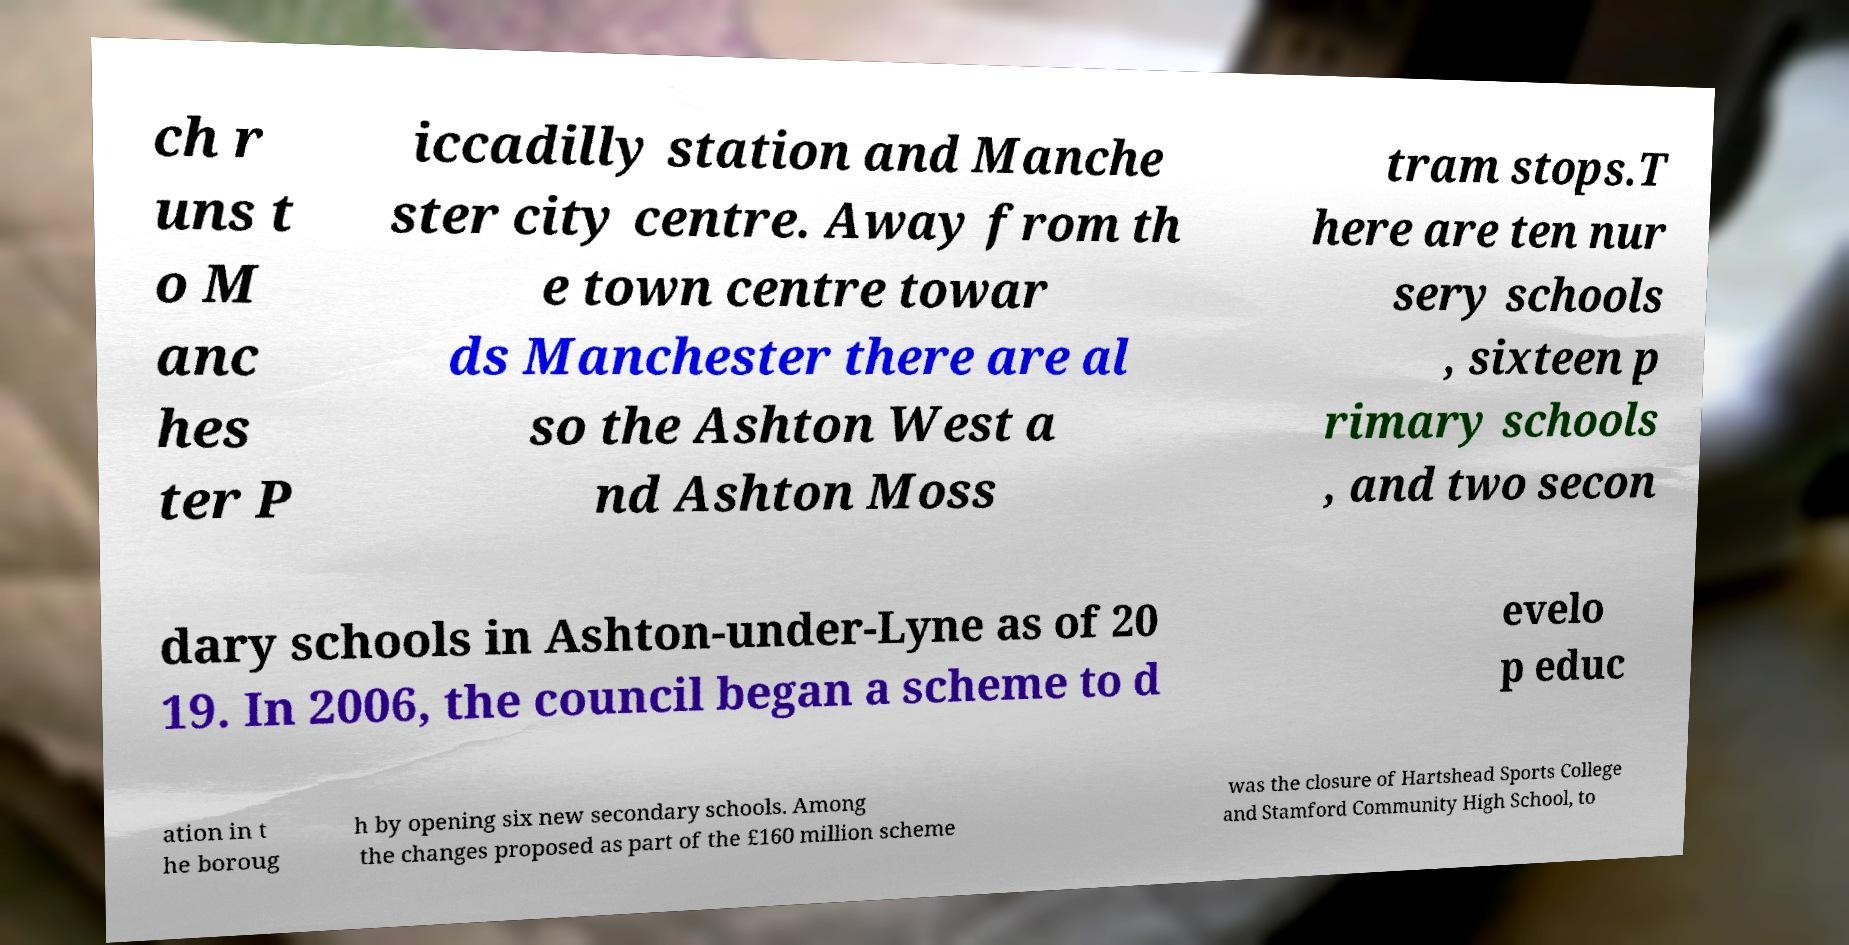Can you read and provide the text displayed in the image?This photo seems to have some interesting text. Can you extract and type it out for me? ch r uns t o M anc hes ter P iccadilly station and Manche ster city centre. Away from th e town centre towar ds Manchester there are al so the Ashton West a nd Ashton Moss tram stops.T here are ten nur sery schools , sixteen p rimary schools , and two secon dary schools in Ashton-under-Lyne as of 20 19. In 2006, the council began a scheme to d evelo p educ ation in t he boroug h by opening six new secondary schools. Among the changes proposed as part of the £160 million scheme was the closure of Hartshead Sports College and Stamford Community High School, to 